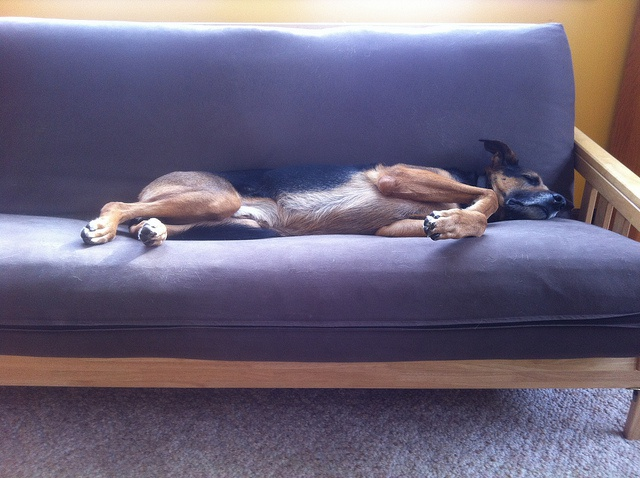Describe the objects in this image and their specific colors. I can see couch in tan, purple, navy, gray, and lavender tones and dog in tan, gray, navy, darkgray, and lightgray tones in this image. 